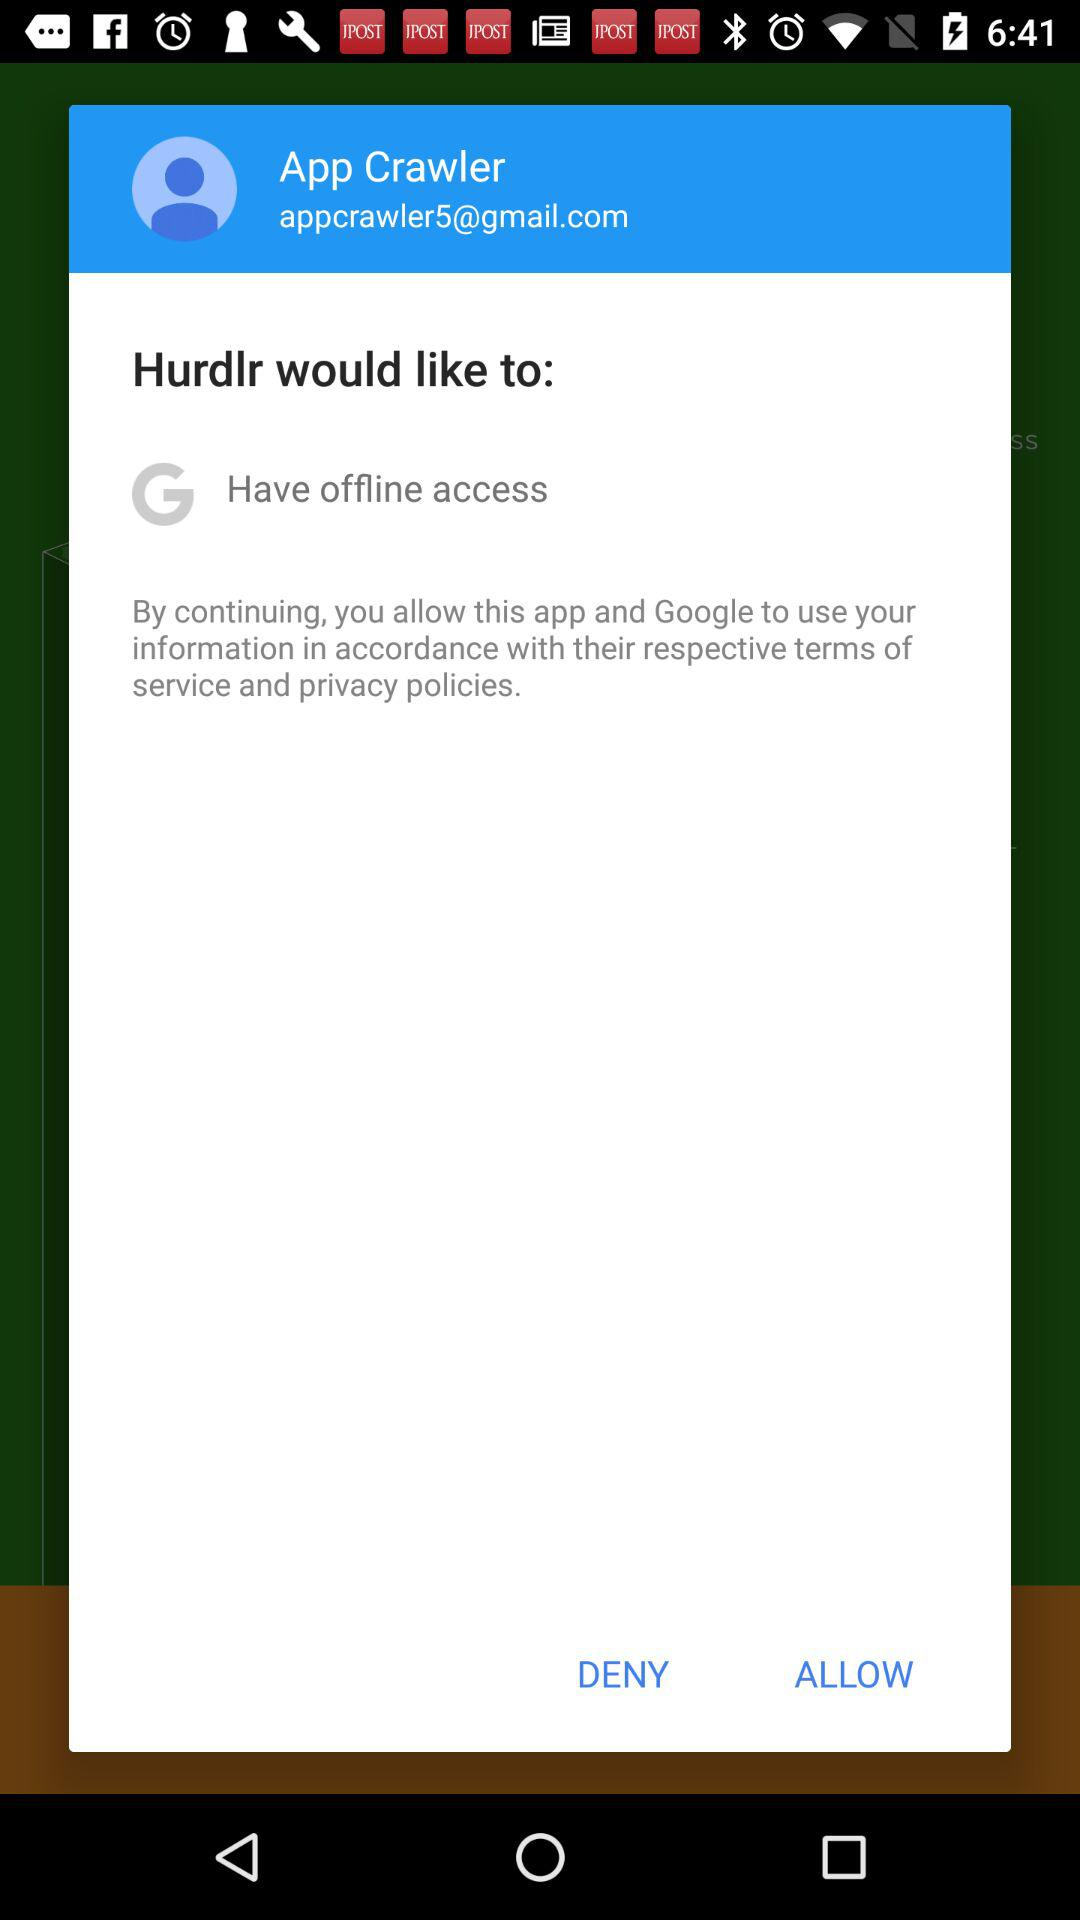What application is asking for permission to have offline access? The application asking for permission to have offline access is "Hurdlr". 